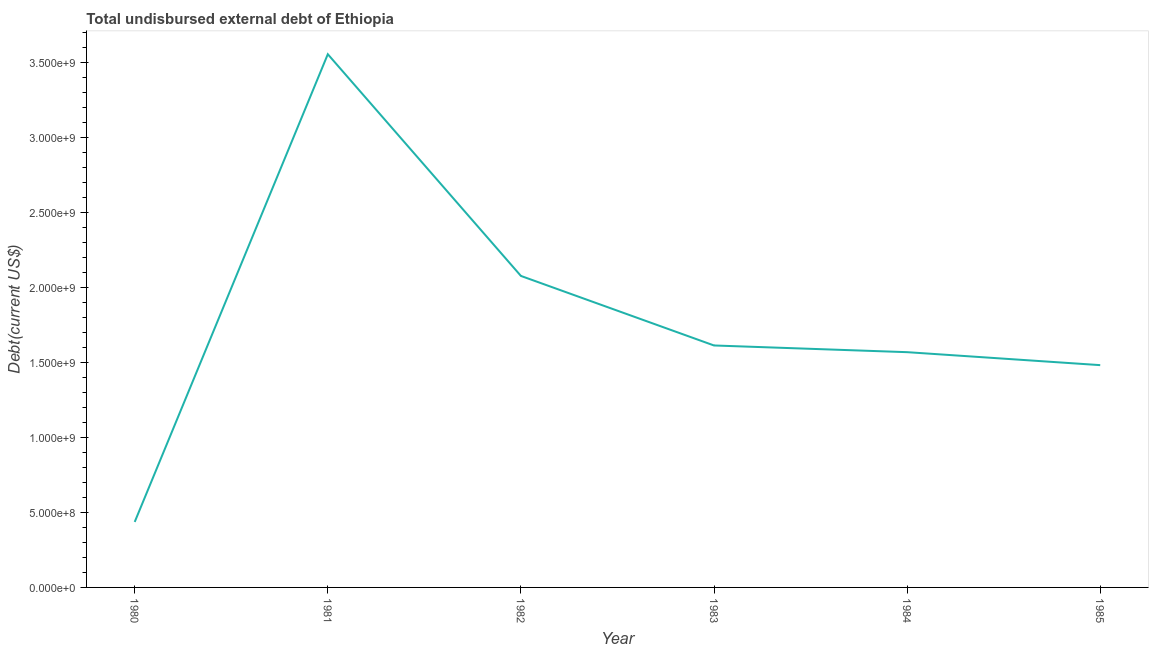What is the total debt in 1984?
Your answer should be very brief. 1.57e+09. Across all years, what is the maximum total debt?
Your answer should be very brief. 3.55e+09. Across all years, what is the minimum total debt?
Provide a succinct answer. 4.36e+08. What is the sum of the total debt?
Offer a terse response. 1.07e+1. What is the difference between the total debt in 1981 and 1982?
Offer a terse response. 1.48e+09. What is the average total debt per year?
Keep it short and to the point. 1.79e+09. What is the median total debt?
Keep it short and to the point. 1.59e+09. What is the ratio of the total debt in 1983 to that in 1984?
Ensure brevity in your answer.  1.03. Is the total debt in 1982 less than that in 1985?
Your answer should be very brief. No. Is the difference between the total debt in 1980 and 1982 greater than the difference between any two years?
Your answer should be compact. No. What is the difference between the highest and the second highest total debt?
Your answer should be very brief. 1.48e+09. What is the difference between the highest and the lowest total debt?
Your response must be concise. 3.12e+09. Does the total debt monotonically increase over the years?
Make the answer very short. No. How many lines are there?
Give a very brief answer. 1. Are the values on the major ticks of Y-axis written in scientific E-notation?
Make the answer very short. Yes. Does the graph contain any zero values?
Keep it short and to the point. No. Does the graph contain grids?
Ensure brevity in your answer.  No. What is the title of the graph?
Keep it short and to the point. Total undisbursed external debt of Ethiopia. What is the label or title of the Y-axis?
Ensure brevity in your answer.  Debt(current US$). What is the Debt(current US$) of 1980?
Ensure brevity in your answer.  4.36e+08. What is the Debt(current US$) of 1981?
Ensure brevity in your answer.  3.55e+09. What is the Debt(current US$) of 1982?
Your response must be concise. 2.08e+09. What is the Debt(current US$) of 1983?
Your response must be concise. 1.61e+09. What is the Debt(current US$) of 1984?
Provide a succinct answer. 1.57e+09. What is the Debt(current US$) of 1985?
Your answer should be very brief. 1.48e+09. What is the difference between the Debt(current US$) in 1980 and 1981?
Your response must be concise. -3.12e+09. What is the difference between the Debt(current US$) in 1980 and 1982?
Ensure brevity in your answer.  -1.64e+09. What is the difference between the Debt(current US$) in 1980 and 1983?
Your answer should be very brief. -1.18e+09. What is the difference between the Debt(current US$) in 1980 and 1984?
Your response must be concise. -1.13e+09. What is the difference between the Debt(current US$) in 1980 and 1985?
Your answer should be compact. -1.05e+09. What is the difference between the Debt(current US$) in 1981 and 1982?
Your answer should be compact. 1.48e+09. What is the difference between the Debt(current US$) in 1981 and 1983?
Offer a very short reply. 1.94e+09. What is the difference between the Debt(current US$) in 1981 and 1984?
Give a very brief answer. 1.99e+09. What is the difference between the Debt(current US$) in 1981 and 1985?
Your answer should be compact. 2.07e+09. What is the difference between the Debt(current US$) in 1982 and 1983?
Provide a succinct answer. 4.64e+08. What is the difference between the Debt(current US$) in 1982 and 1984?
Keep it short and to the point. 5.08e+08. What is the difference between the Debt(current US$) in 1982 and 1985?
Your answer should be compact. 5.95e+08. What is the difference between the Debt(current US$) in 1983 and 1984?
Provide a short and direct response. 4.46e+07. What is the difference between the Debt(current US$) in 1983 and 1985?
Provide a succinct answer. 1.31e+08. What is the difference between the Debt(current US$) in 1984 and 1985?
Offer a very short reply. 8.65e+07. What is the ratio of the Debt(current US$) in 1980 to that in 1981?
Provide a short and direct response. 0.12. What is the ratio of the Debt(current US$) in 1980 to that in 1982?
Offer a terse response. 0.21. What is the ratio of the Debt(current US$) in 1980 to that in 1983?
Your answer should be very brief. 0.27. What is the ratio of the Debt(current US$) in 1980 to that in 1984?
Provide a succinct answer. 0.28. What is the ratio of the Debt(current US$) in 1980 to that in 1985?
Give a very brief answer. 0.29. What is the ratio of the Debt(current US$) in 1981 to that in 1982?
Your answer should be very brief. 1.71. What is the ratio of the Debt(current US$) in 1981 to that in 1983?
Your response must be concise. 2.2. What is the ratio of the Debt(current US$) in 1981 to that in 1984?
Your answer should be compact. 2.27. What is the ratio of the Debt(current US$) in 1981 to that in 1985?
Provide a succinct answer. 2.4. What is the ratio of the Debt(current US$) in 1982 to that in 1983?
Give a very brief answer. 1.29. What is the ratio of the Debt(current US$) in 1982 to that in 1984?
Your answer should be compact. 1.32. What is the ratio of the Debt(current US$) in 1982 to that in 1985?
Provide a succinct answer. 1.4. What is the ratio of the Debt(current US$) in 1983 to that in 1984?
Your response must be concise. 1.03. What is the ratio of the Debt(current US$) in 1983 to that in 1985?
Make the answer very short. 1.09. What is the ratio of the Debt(current US$) in 1984 to that in 1985?
Your answer should be very brief. 1.06. 